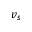Convert formula to latex. <formula><loc_0><loc_0><loc_500><loc_500>v _ { s }</formula> 